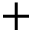<formula> <loc_0><loc_0><loc_500><loc_500>+</formula> 